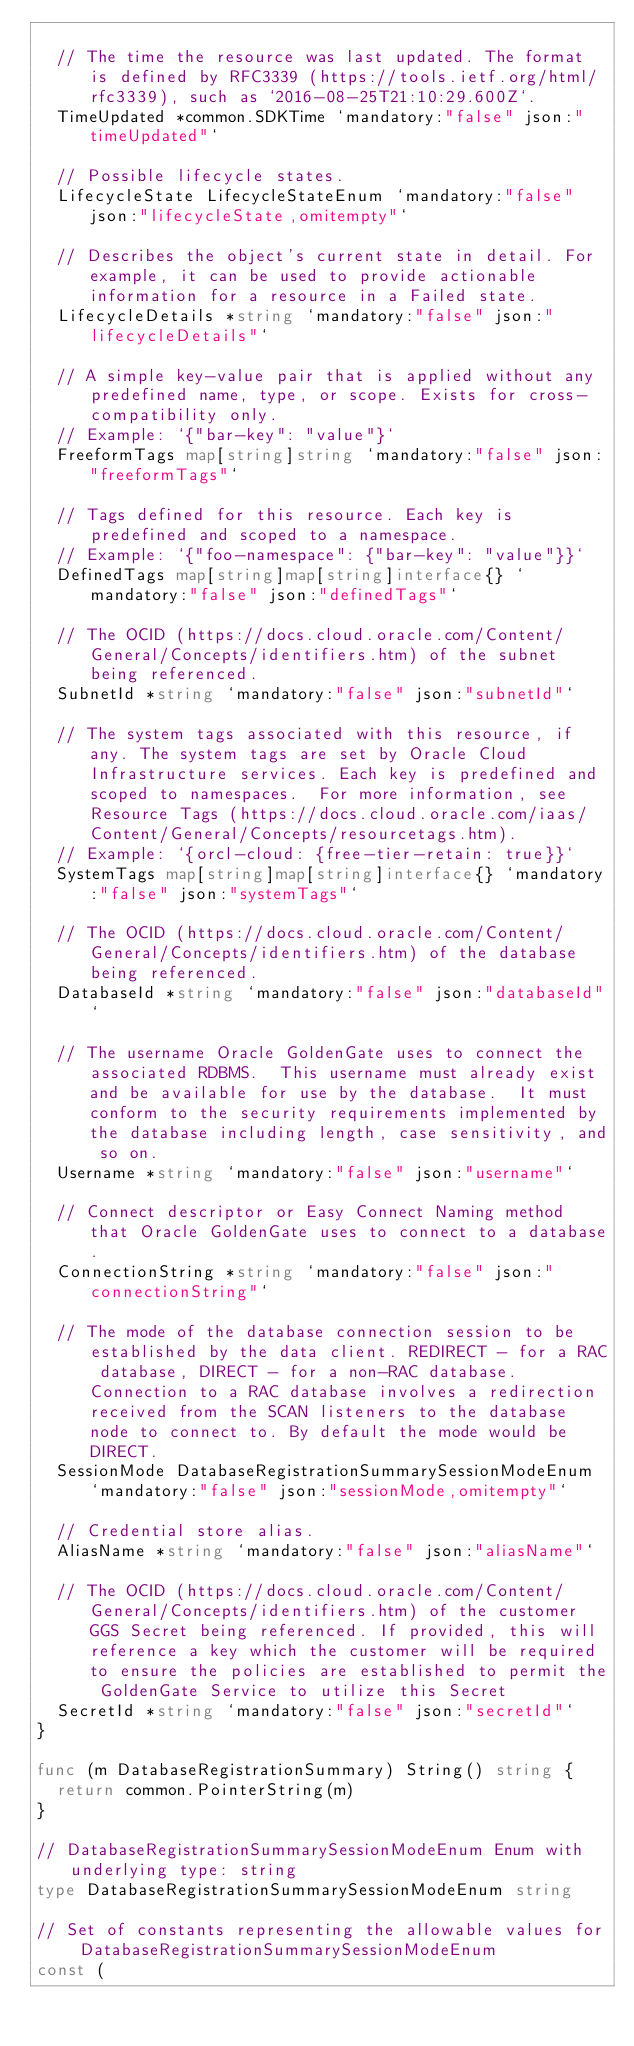<code> <loc_0><loc_0><loc_500><loc_500><_Go_>
	// The time the resource was last updated. The format is defined by RFC3339 (https://tools.ietf.org/html/rfc3339), such as `2016-08-25T21:10:29.600Z`.
	TimeUpdated *common.SDKTime `mandatory:"false" json:"timeUpdated"`

	// Possible lifecycle states.
	LifecycleState LifecycleStateEnum `mandatory:"false" json:"lifecycleState,omitempty"`

	// Describes the object's current state in detail. For example, it can be used to provide actionable information for a resource in a Failed state.
	LifecycleDetails *string `mandatory:"false" json:"lifecycleDetails"`

	// A simple key-value pair that is applied without any predefined name, type, or scope. Exists for cross-compatibility only.
	// Example: `{"bar-key": "value"}`
	FreeformTags map[string]string `mandatory:"false" json:"freeformTags"`

	// Tags defined for this resource. Each key is predefined and scoped to a namespace.
	// Example: `{"foo-namespace": {"bar-key": "value"}}`
	DefinedTags map[string]map[string]interface{} `mandatory:"false" json:"definedTags"`

	// The OCID (https://docs.cloud.oracle.com/Content/General/Concepts/identifiers.htm) of the subnet being referenced.
	SubnetId *string `mandatory:"false" json:"subnetId"`

	// The system tags associated with this resource, if any. The system tags are set by Oracle Cloud Infrastructure services. Each key is predefined and scoped to namespaces.  For more information, see Resource Tags (https://docs.cloud.oracle.com/iaas/Content/General/Concepts/resourcetags.htm).
	// Example: `{orcl-cloud: {free-tier-retain: true}}`
	SystemTags map[string]map[string]interface{} `mandatory:"false" json:"systemTags"`

	// The OCID (https://docs.cloud.oracle.com/Content/General/Concepts/identifiers.htm) of the database being referenced.
	DatabaseId *string `mandatory:"false" json:"databaseId"`

	// The username Oracle GoldenGate uses to connect the associated RDBMS.  This username must already exist and be available for use by the database.  It must conform to the security requirements implemented by the database including length, case sensitivity, and so on.
	Username *string `mandatory:"false" json:"username"`

	// Connect descriptor or Easy Connect Naming method that Oracle GoldenGate uses to connect to a database.
	ConnectionString *string `mandatory:"false" json:"connectionString"`

	// The mode of the database connection session to be established by the data client. REDIRECT - for a RAC database, DIRECT - for a non-RAC database. Connection to a RAC database involves a redirection received from the SCAN listeners to the database node to connect to. By default the mode would be DIRECT.
	SessionMode DatabaseRegistrationSummarySessionModeEnum `mandatory:"false" json:"sessionMode,omitempty"`

	// Credential store alias.
	AliasName *string `mandatory:"false" json:"aliasName"`

	// The OCID (https://docs.cloud.oracle.com/Content/General/Concepts/identifiers.htm) of the customer GGS Secret being referenced. If provided, this will reference a key which the customer will be required to ensure the policies are established to permit the GoldenGate Service to utilize this Secret
	SecretId *string `mandatory:"false" json:"secretId"`
}

func (m DatabaseRegistrationSummary) String() string {
	return common.PointerString(m)
}

// DatabaseRegistrationSummarySessionModeEnum Enum with underlying type: string
type DatabaseRegistrationSummarySessionModeEnum string

// Set of constants representing the allowable values for DatabaseRegistrationSummarySessionModeEnum
const (</code> 